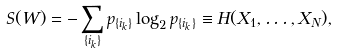<formula> <loc_0><loc_0><loc_500><loc_500>S ( W ) = - \sum _ { \{ i _ { k } \} } p _ { \{ i _ { k } \} } \log _ { 2 } p _ { \{ i _ { k } \} } \equiv H ( X _ { 1 } , \dots , X _ { N } ) ,</formula> 